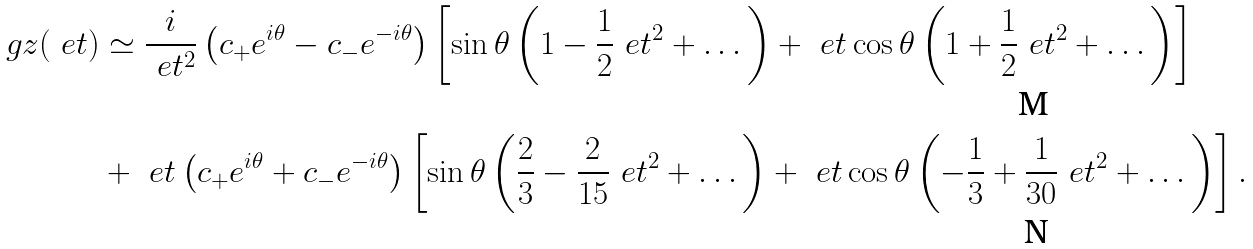Convert formula to latex. <formula><loc_0><loc_0><loc_500><loc_500>\ g z ( \ e t ) & \simeq \frac { i } { \ e t ^ { 2 } } \left ( c _ { + } e ^ { i \theta } - c _ { - } e ^ { - i \theta } \right ) \left [ \sin \theta \left ( 1 - \frac { 1 } { 2 } \ e t ^ { 2 } + \dots \right ) + \ e t \cos \theta \left ( 1 + \frac { 1 } { 2 } \ e t ^ { 2 } + \dots \right ) \right ] \\ & + \ e t \left ( c _ { + } e ^ { i \theta } + c _ { - } e ^ { - i \theta } \right ) \left [ \sin \theta \left ( \frac { 2 } { 3 } - \frac { 2 } { 1 5 } \ e t ^ { 2 } + \dots \right ) + \ e t \cos \theta \left ( - \frac { 1 } { 3 } + \frac { 1 } { 3 0 } \ e t ^ { 2 } + \dots \right ) \right ] .</formula> 